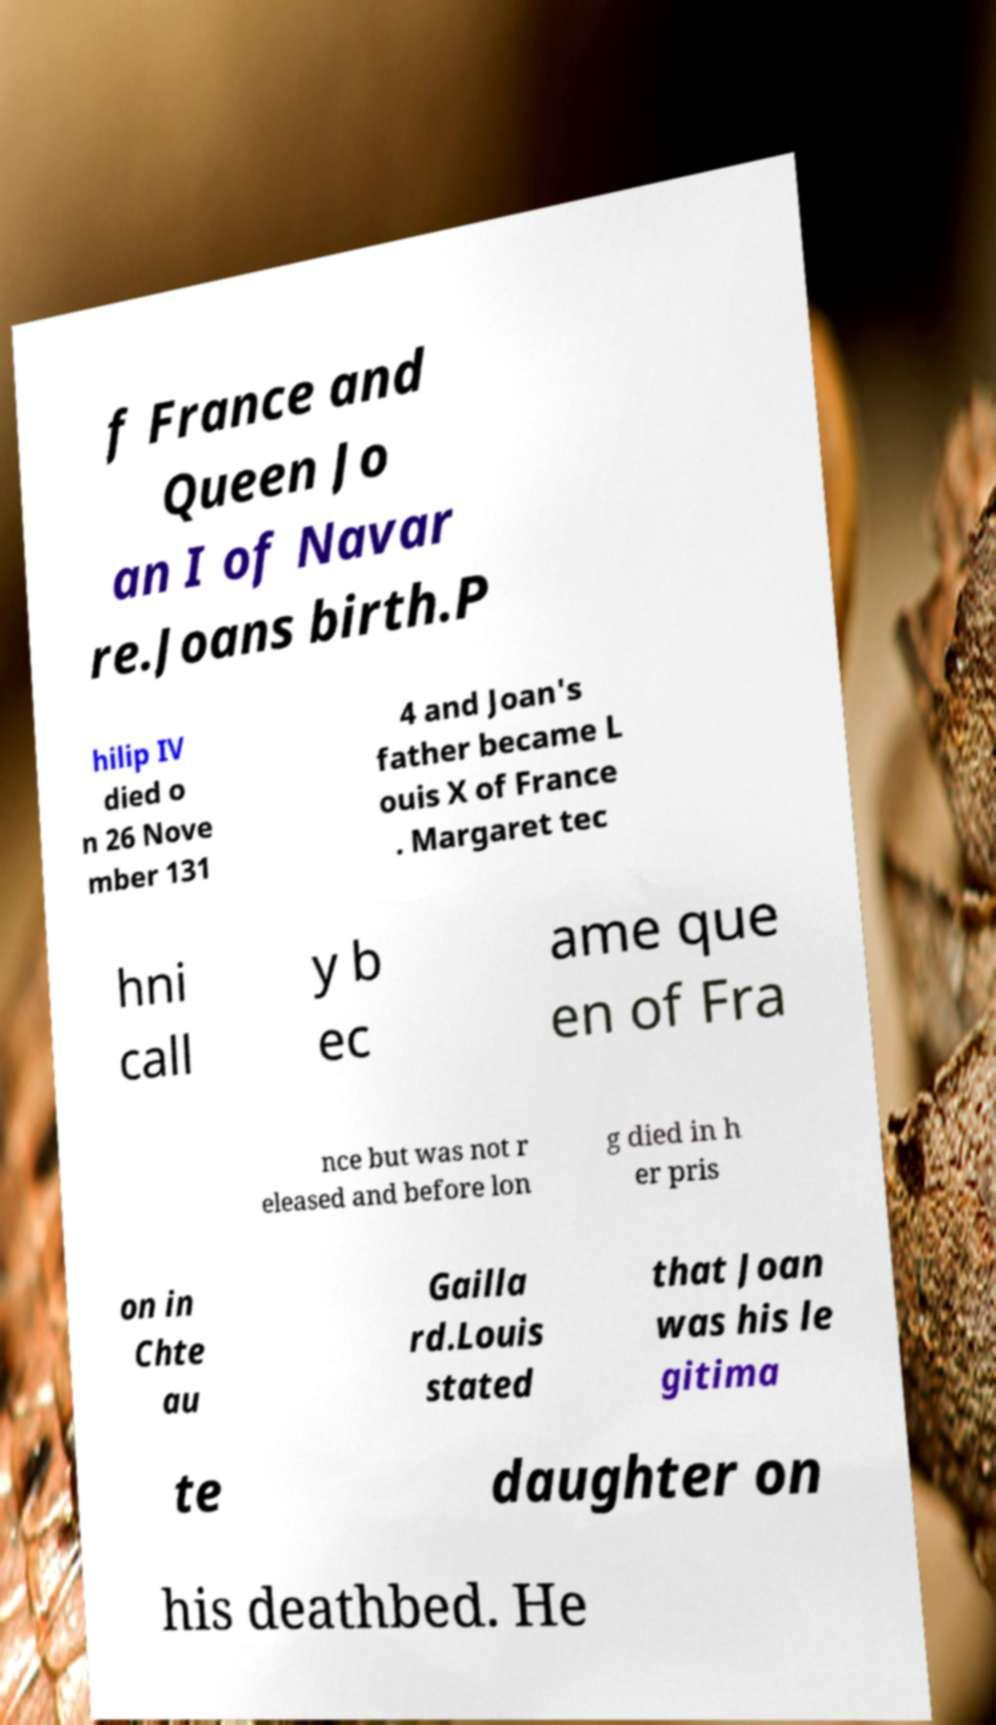Can you read and provide the text displayed in the image?This photo seems to have some interesting text. Can you extract and type it out for me? f France and Queen Jo an I of Navar re.Joans birth.P hilip IV died o n 26 Nove mber 131 4 and Joan's father became L ouis X of France . Margaret tec hni call y b ec ame que en of Fra nce but was not r eleased and before lon g died in h er pris on in Chte au Gailla rd.Louis stated that Joan was his le gitima te daughter on his deathbed. He 